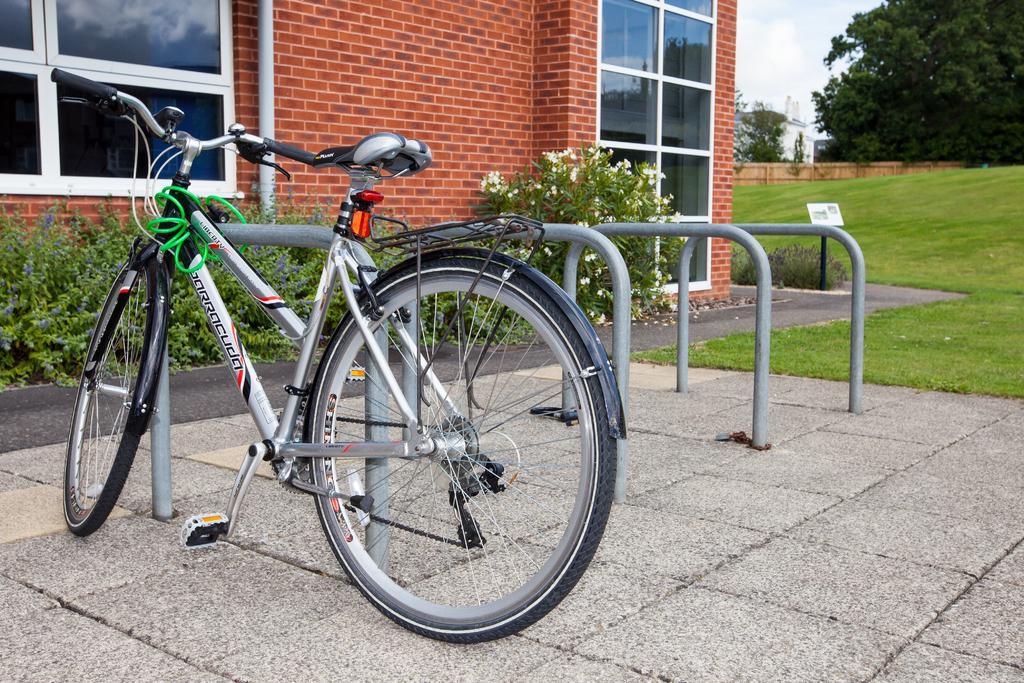Could you give a brief overview of what you see in this image? In the center of the image, we can see a bicycle and there are railings. In the background, there are trees, plants, building and we can see windows and a pole. At the top, there is sky and at the bottom, there is ground and road. 